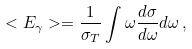Convert formula to latex. <formula><loc_0><loc_0><loc_500><loc_500>< E _ { \gamma } > = \frac { 1 } { \sigma _ { T } } \int \omega \frac { d \sigma } { d \omega } d \omega \, ,</formula> 